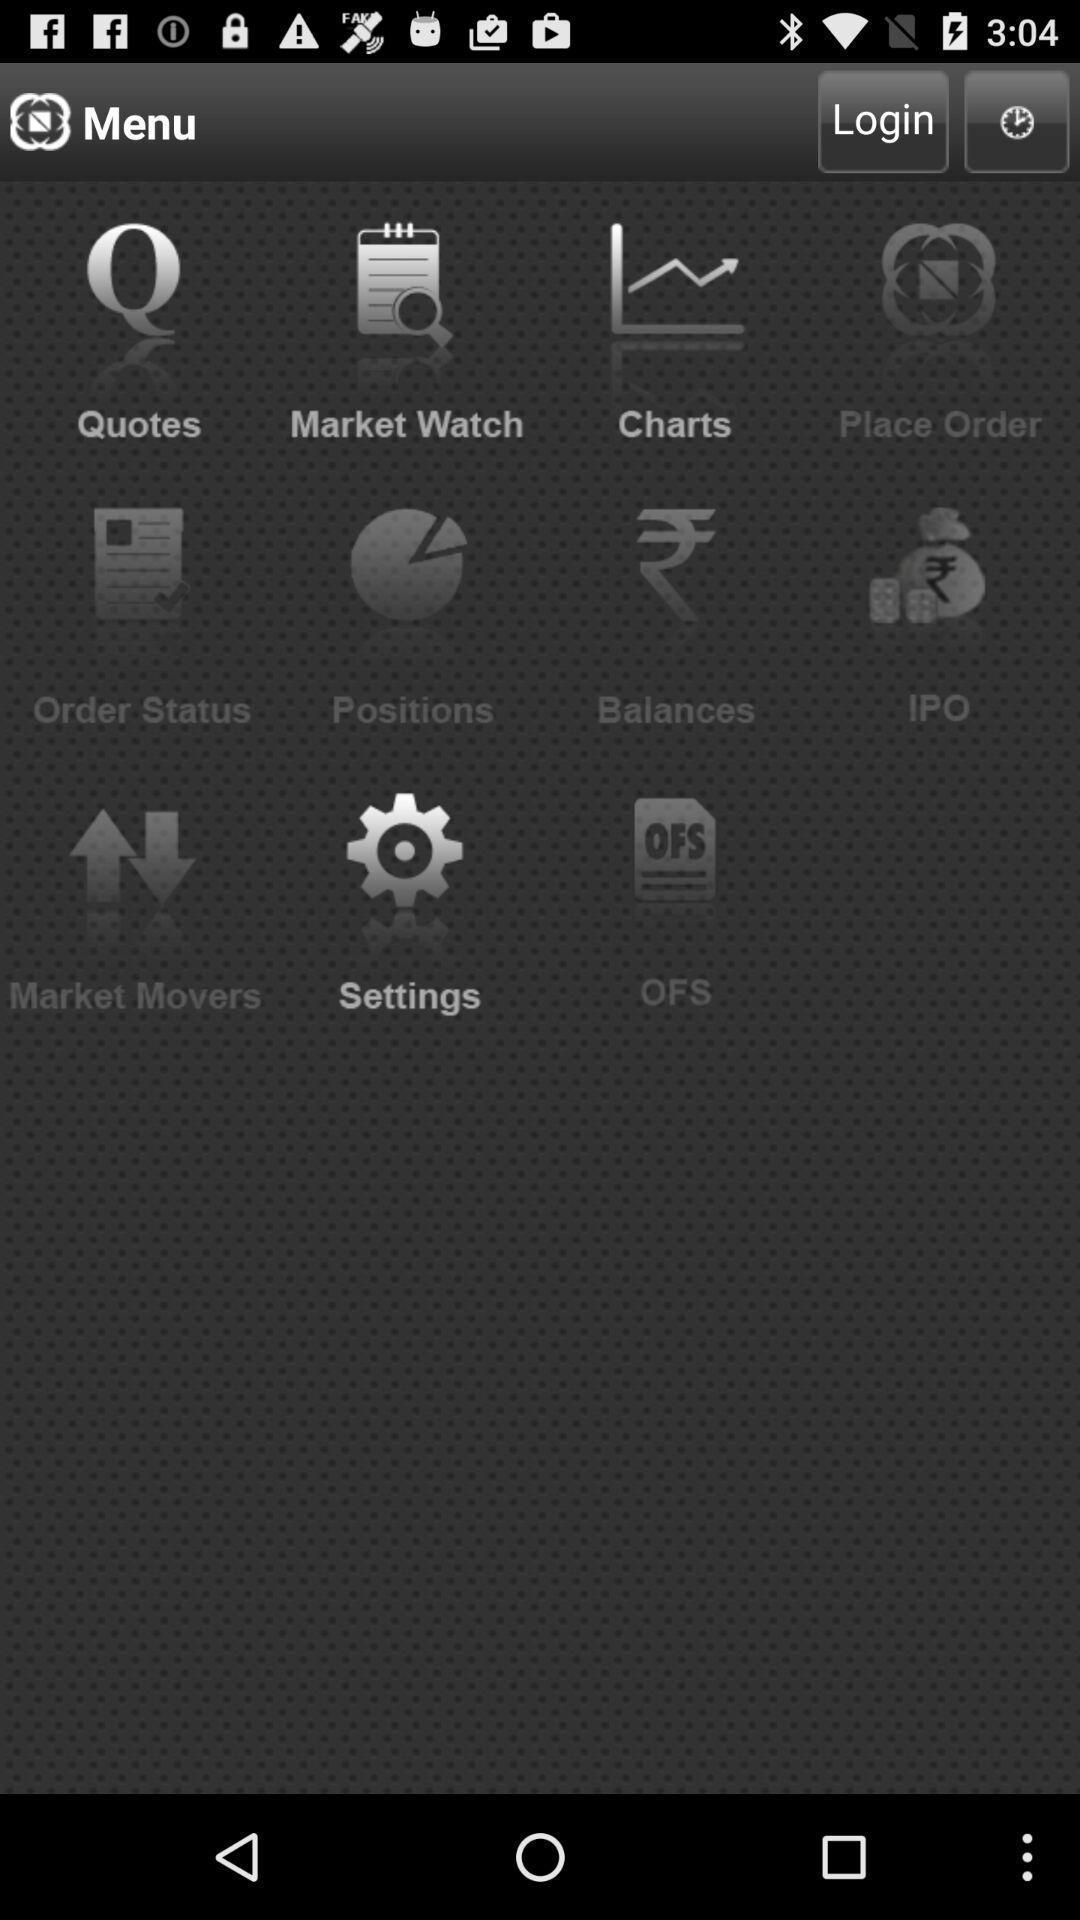Tell me what you see in this picture. Page is displaying menu options. 